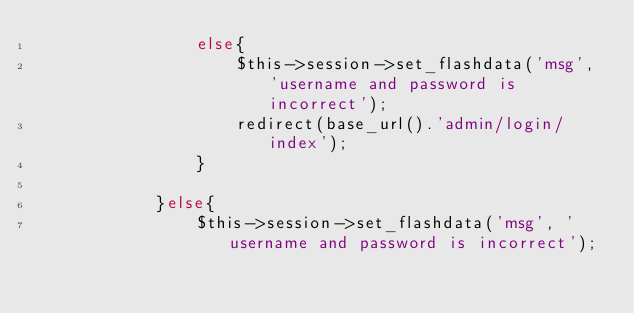<code> <loc_0><loc_0><loc_500><loc_500><_PHP_>				else{
					$this->session->set_flashdata('msg', 'username and password is incorrect');
				    redirect(base_url().'admin/login/index');
				}

			}else{
				$this->session->set_flashdata('msg', 'username and password is incorrect');</code> 